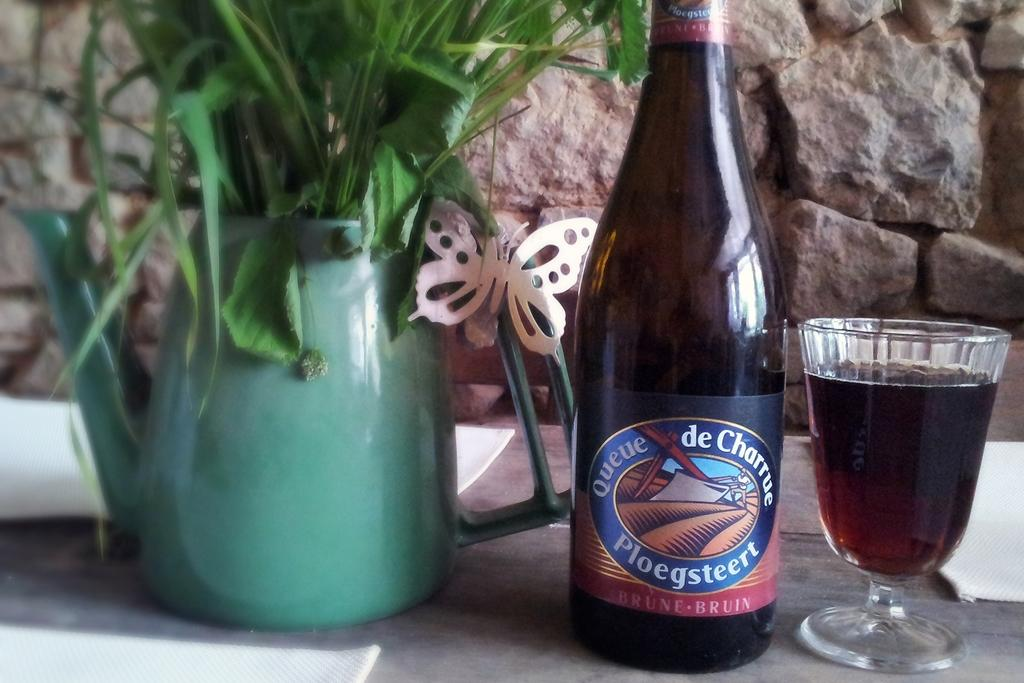<image>
Provide a brief description of the given image. A wine bottle that says Queue de Charrue Ploegsteert beside a wine glass filled 